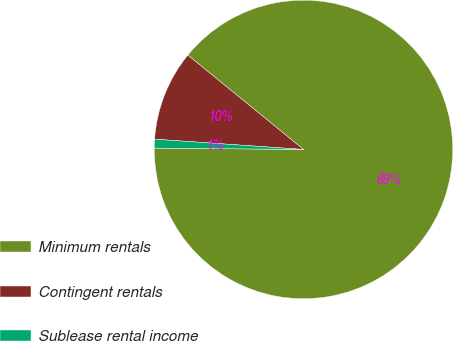Convert chart. <chart><loc_0><loc_0><loc_500><loc_500><pie_chart><fcel>Minimum rentals<fcel>Contingent rentals<fcel>Sublease rental income<nl><fcel>89.26%<fcel>9.79%<fcel>0.95%<nl></chart> 